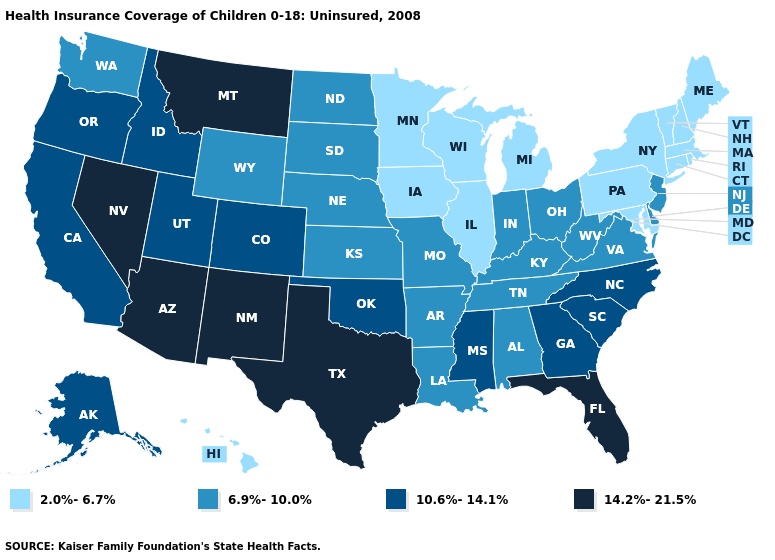What is the highest value in the USA?
Write a very short answer. 14.2%-21.5%. Does New Jersey have a lower value than Montana?
Write a very short answer. Yes. Name the states that have a value in the range 14.2%-21.5%?
Give a very brief answer. Arizona, Florida, Montana, Nevada, New Mexico, Texas. Which states have the highest value in the USA?
Quick response, please. Arizona, Florida, Montana, Nevada, New Mexico, Texas. Which states have the lowest value in the USA?
Write a very short answer. Connecticut, Hawaii, Illinois, Iowa, Maine, Maryland, Massachusetts, Michigan, Minnesota, New Hampshire, New York, Pennsylvania, Rhode Island, Vermont, Wisconsin. Does the first symbol in the legend represent the smallest category?
Short answer required. Yes. What is the lowest value in states that border New York?
Concise answer only. 2.0%-6.7%. Does Arkansas have the lowest value in the USA?
Answer briefly. No. How many symbols are there in the legend?
Answer briefly. 4. Does the map have missing data?
Keep it brief. No. What is the value of Hawaii?
Write a very short answer. 2.0%-6.7%. Does the map have missing data?
Write a very short answer. No. Name the states that have a value in the range 2.0%-6.7%?
Answer briefly. Connecticut, Hawaii, Illinois, Iowa, Maine, Maryland, Massachusetts, Michigan, Minnesota, New Hampshire, New York, Pennsylvania, Rhode Island, Vermont, Wisconsin. What is the highest value in the South ?
Concise answer only. 14.2%-21.5%. Among the states that border Idaho , which have the highest value?
Keep it brief. Montana, Nevada. 